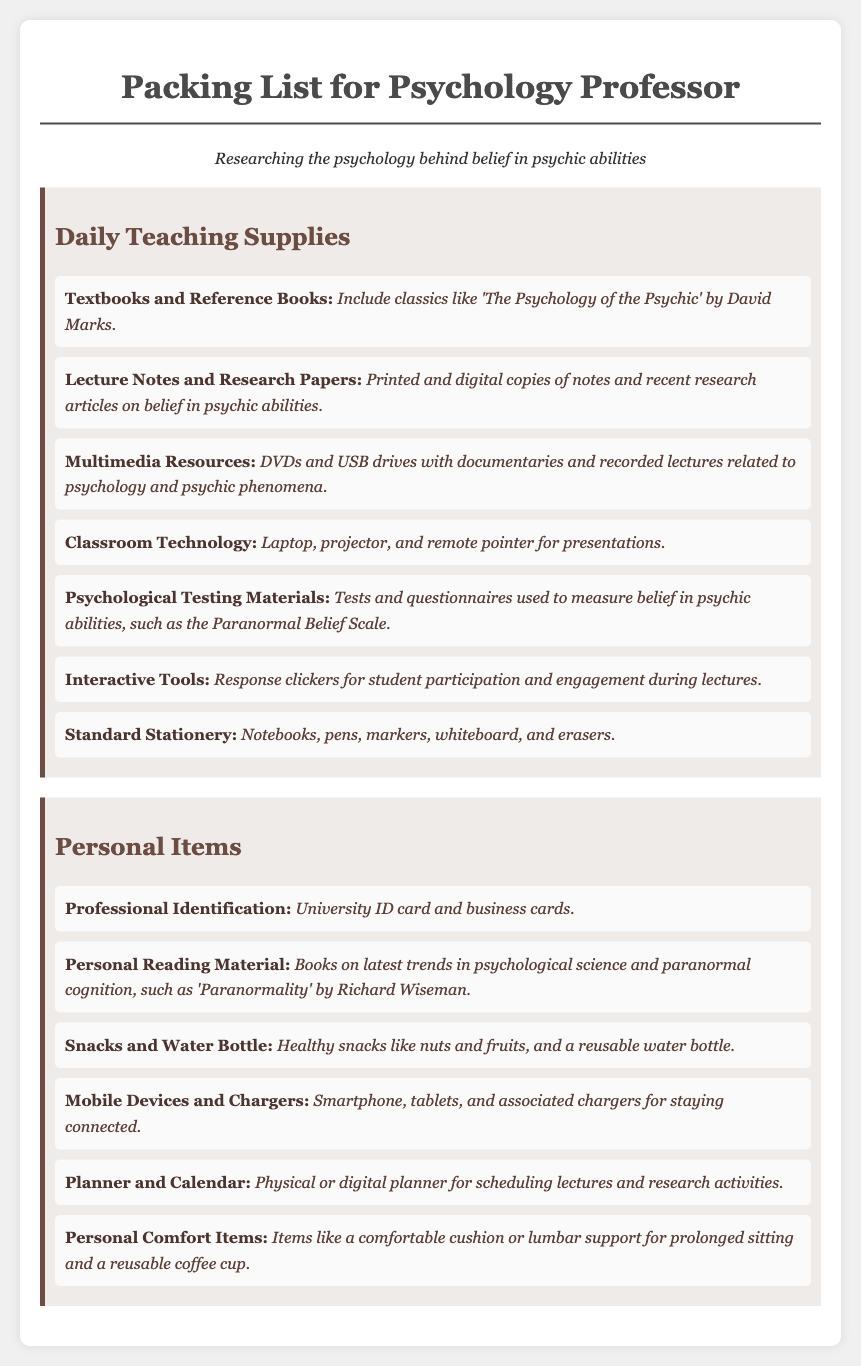what is included in the Daily Teaching Supplies category? The Daily Teaching Supplies category includes items like textbooks, lecture notes, multimedia resources, and standard stationery.
Answer: textbooks and reference books, lecture notes and research papers, multimedia resources, classroom technology, psychological testing materials, interactive tools, standard stationery what book is suggested for reading about the psychology of the psychic? The document mentions 'The Psychology of the Psychic' by David Marks as a classic.
Answer: The Psychology of the Psychic what item is needed for student participation during lectures? The document lists response clickers as tools for engaging students.
Answer: Response clickers how many types of personal comfort items are listed? The document mentions one category of personal comfort items, which includes cushions or lumbar support.
Answer: one what type of resources are DVDs and USB drives classified as? DVDs and USB drives are categorized under multimedia resources in the teaching supplies.
Answer: multimedia resources what should be included for scheduling research activities? A planner or calendar is necessary for scheduling lectures and research activities.
Answer: Planner and Calendar which psychological testing material is mentioned for measuring belief? The Paranormal Belief Scale is specified as a testing tool in the document.
Answer: Paranormal Belief Scale what type of personal reading material is recommended? Personal reading material includes books on trends in psychological science and paranormal cognition.
Answer: Books on latest trends in psychological science and paranormal cognition how many items are listed under Personal Items? There are six items mentioned under the Personal Items category.
Answer: six 